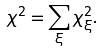<formula> <loc_0><loc_0><loc_500><loc_500>\chi ^ { 2 } = \sum _ { \xi } \chi ^ { 2 } _ { \xi } .</formula> 